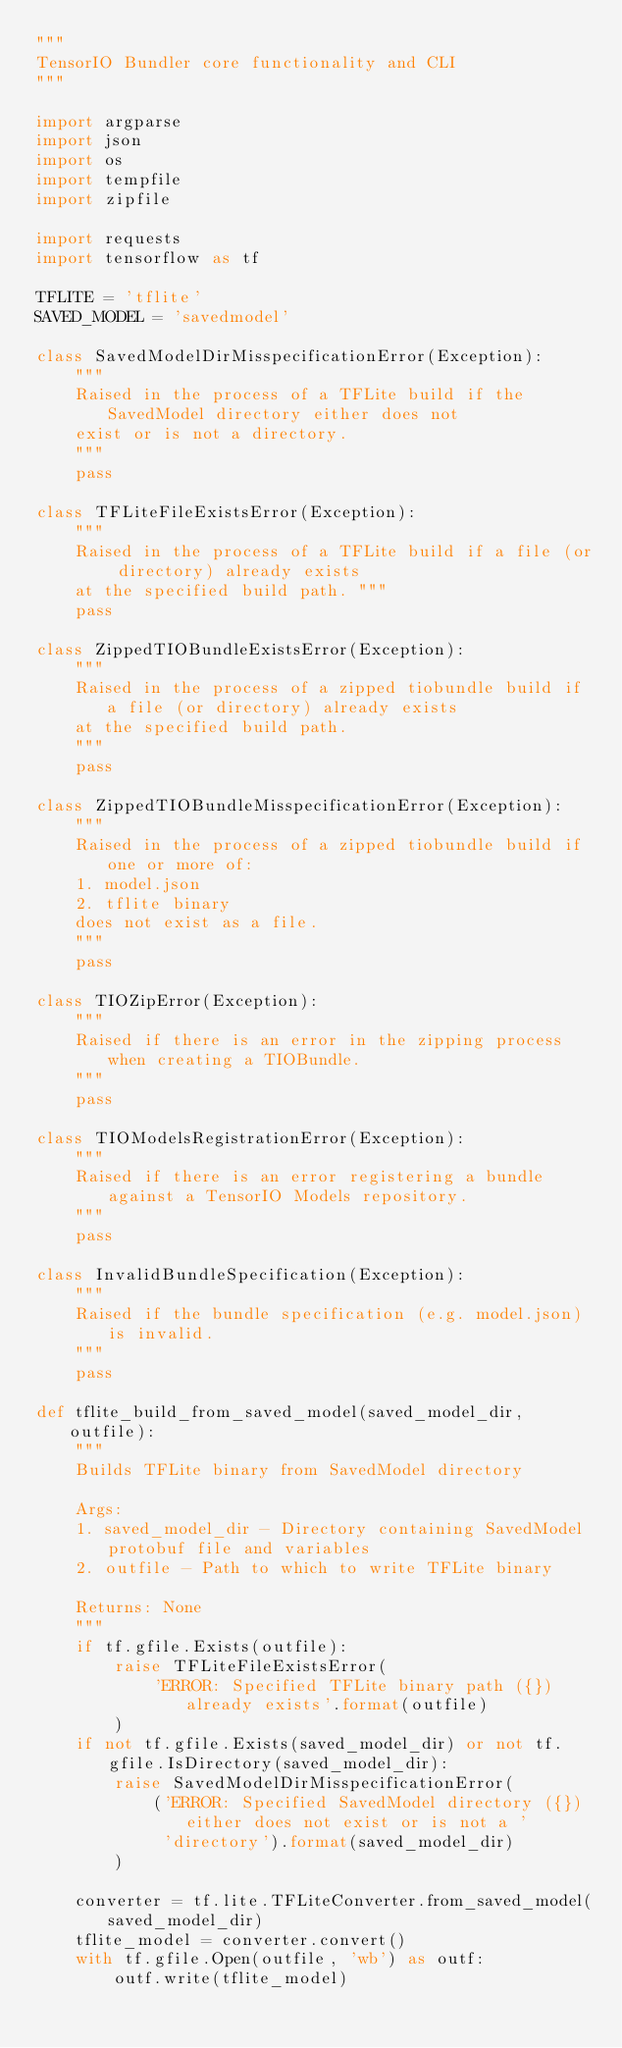<code> <loc_0><loc_0><loc_500><loc_500><_Python_>"""
TensorIO Bundler core functionality and CLI
"""

import argparse
import json
import os
import tempfile
import zipfile

import requests
import tensorflow as tf

TFLITE = 'tflite'
SAVED_MODEL = 'savedmodel'

class SavedModelDirMisspecificationError(Exception):
    """
    Raised in the process of a TFLite build if the SavedModel directory either does not
    exist or is not a directory.
    """
    pass

class TFLiteFileExistsError(Exception):
    """
    Raised in the process of a TFLite build if a file (or directory) already exists
    at the specified build path. """
    pass

class ZippedTIOBundleExistsError(Exception):
    """
    Raised in the process of a zipped tiobundle build if a file (or directory) already exists
    at the specified build path.
    """
    pass

class ZippedTIOBundleMisspecificationError(Exception):
    """
    Raised in the process of a zipped tiobundle build if one or more of:
    1. model.json
    2. tflite binary
    does not exist as a file.
    """
    pass

class TIOZipError(Exception):
    """
    Raised if there is an error in the zipping process when creating a TIOBundle.
    """
    pass

class TIOModelsRegistrationError(Exception):
    """
    Raised if there is an error registering a bundle against a TensorIO Models repository.
    """
    pass

class InvalidBundleSpecification(Exception):
    """
    Raised if the bundle specification (e.g. model.json) is invalid.
    """
    pass

def tflite_build_from_saved_model(saved_model_dir, outfile):
    """
    Builds TFLite binary from SavedModel directory

    Args:
    1. saved_model_dir - Directory containing SavedModel protobuf file and variables
    2. outfile - Path to which to write TFLite binary

    Returns: None
    """
    if tf.gfile.Exists(outfile):
        raise TFLiteFileExistsError(
            'ERROR: Specified TFLite binary path ({}) already exists'.format(outfile)
        )
    if not tf.gfile.Exists(saved_model_dir) or not tf.gfile.IsDirectory(saved_model_dir):
        raise SavedModelDirMisspecificationError(
            ('ERROR: Specified SavedModel directory ({}) either does not exist or is not a '
             'directory').format(saved_model_dir)
        )

    converter = tf.lite.TFLiteConverter.from_saved_model(saved_model_dir)
    tflite_model = converter.convert()
    with tf.gfile.Open(outfile, 'wb') as outf:
        outf.write(tflite_model)
</code> 